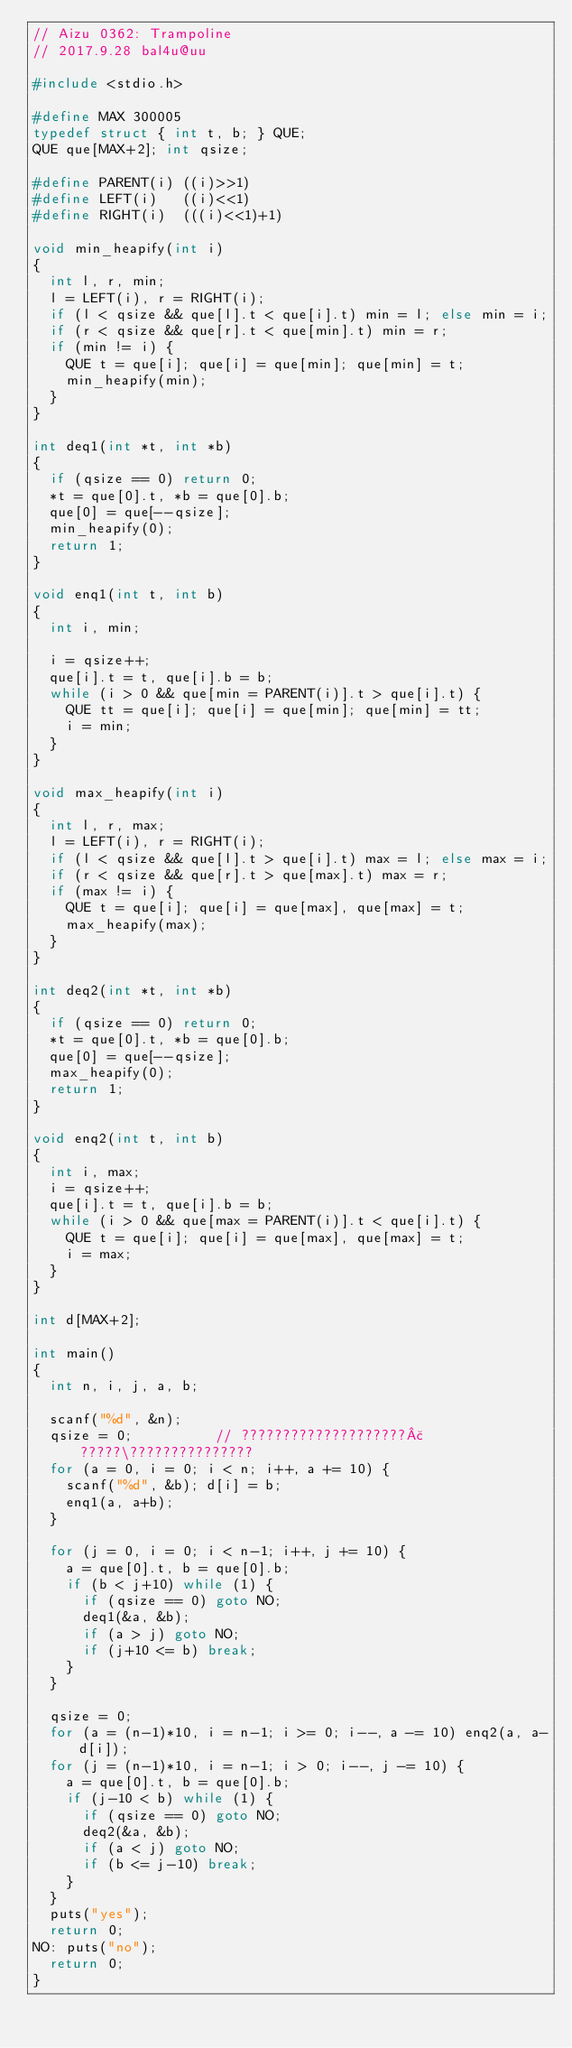Convert code to text. <code><loc_0><loc_0><loc_500><loc_500><_C_>// Aizu 0362: Trampoline
// 2017.9.28 bal4u@uu

#include <stdio.h>

#define MAX 300005
typedef struct { int t, b; } QUE;
QUE que[MAX+2]; int qsize;

#define PARENT(i) ((i)>>1)
#define LEFT(i)   ((i)<<1)
#define RIGHT(i)  (((i)<<1)+1)

void min_heapify(int i)
{
  int l, r, min;
  l = LEFT(i), r = RIGHT(i);
  if (l < qsize && que[l].t < que[i].t) min = l; else min = i;
  if (r < qsize && que[r].t < que[min].t) min = r;
  if (min != i) {
    QUE t = que[i]; que[i] = que[min]; que[min] = t;
    min_heapify(min);
  }
}

int deq1(int *t, int *b)
{
  if (qsize == 0) return 0;
  *t = que[0].t, *b = que[0].b;
  que[0] = que[--qsize];
  min_heapify(0);
  return 1;
}

void enq1(int t, int b)
{
  int i, min;

  i = qsize++;
  que[i].t = t, que[i].b = b;
  while (i > 0 && que[min = PARENT(i)].t > que[i].t) {
    QUE tt = que[i]; que[i] = que[min]; que[min] = tt;
    i = min;
  }
}

void max_heapify(int i)
{
	int l, r, max;
	l = LEFT(i), r = RIGHT(i);
	if (l < qsize && que[l].t > que[i].t) max = l; else max = i;
	if (r < qsize && que[r].t > que[max].t)	max = r;
	if (max != i) {
		QUE t = que[i]; que[i] = que[max], que[max] = t;
		max_heapify(max);
	}
}

int deq2(int *t, int *b)
{
	if (qsize == 0) return 0;
	*t = que[0].t, *b = que[0].b;
	que[0] = que[--qsize];
	max_heapify(0);
	return 1;
}

void enq2(int t, int b)
{
	int i, max;
	i = qsize++;
	que[i].t = t, que[i].b = b;
	while (i > 0 && que[max = PARENT(i)].t < que[i].t) {
		QUE t = que[i]; que[i] = que[max], que[max] = t;
		i = max;
	}
}

int d[MAX+2];

int main()
{
	int n, i, j, a, b;

	scanf("%d", &n);
	qsize = 0;					// ????????????????????£?????\???????????????
	for (a = 0, i = 0; i < n; i++, a += 10)	{
		scanf("%d", &b); d[i] = b;
		enq1(a, a+b);
	}

	for (j = 0, i = 0; i < n-1; i++, j += 10) {
		a = que[0].t, b = que[0].b;
		if (b < j+10) while (1) {
			if (qsize == 0) goto NO;
			deq1(&a, &b);
			if (a > j) goto NO;
			if (j+10 <= b) break;
		}
	}

	qsize = 0;
	for (a = (n-1)*10, i = n-1; i >= 0; i--, a -= 10) enq2(a, a-d[i]);
	for (j = (n-1)*10, i = n-1; i > 0; i--, j -= 10) {
		a = que[0].t, b = que[0].b;
		if (j-10 < b) while (1) {
			if (qsize == 0) goto NO;
			deq2(&a, &b);
			if (a < j) goto NO;
			if (b <= j-10) break;
		}
	}
	puts("yes");
	return 0;
NO: puts("no");
	return 0;
}</code> 